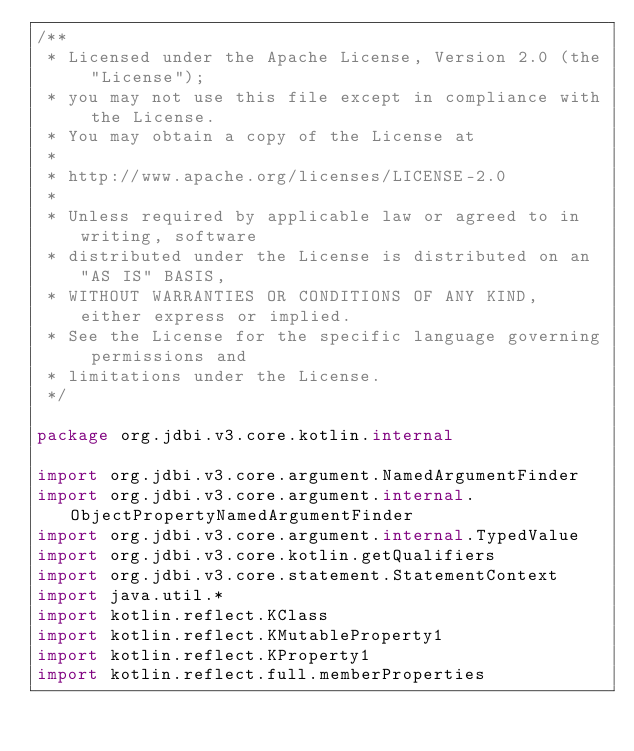Convert code to text. <code><loc_0><loc_0><loc_500><loc_500><_Kotlin_>/**
 * Licensed under the Apache License, Version 2.0 (the "License");
 * you may not use this file except in compliance with the License.
 * You may obtain a copy of the License at
 *
 * http://www.apache.org/licenses/LICENSE-2.0
 *
 * Unless required by applicable law or agreed to in writing, software
 * distributed under the License is distributed on an "AS IS" BASIS,
 * WITHOUT WARRANTIES OR CONDITIONS OF ANY KIND, either express or implied.
 * See the License for the specific language governing permissions and
 * limitations under the License.
 */

package org.jdbi.v3.core.kotlin.internal

import org.jdbi.v3.core.argument.NamedArgumentFinder
import org.jdbi.v3.core.argument.internal.ObjectPropertyNamedArgumentFinder
import org.jdbi.v3.core.argument.internal.TypedValue
import org.jdbi.v3.core.kotlin.getQualifiers
import org.jdbi.v3.core.statement.StatementContext
import java.util.*
import kotlin.reflect.KClass
import kotlin.reflect.KMutableProperty1
import kotlin.reflect.KProperty1
import kotlin.reflect.full.memberProperties</code> 